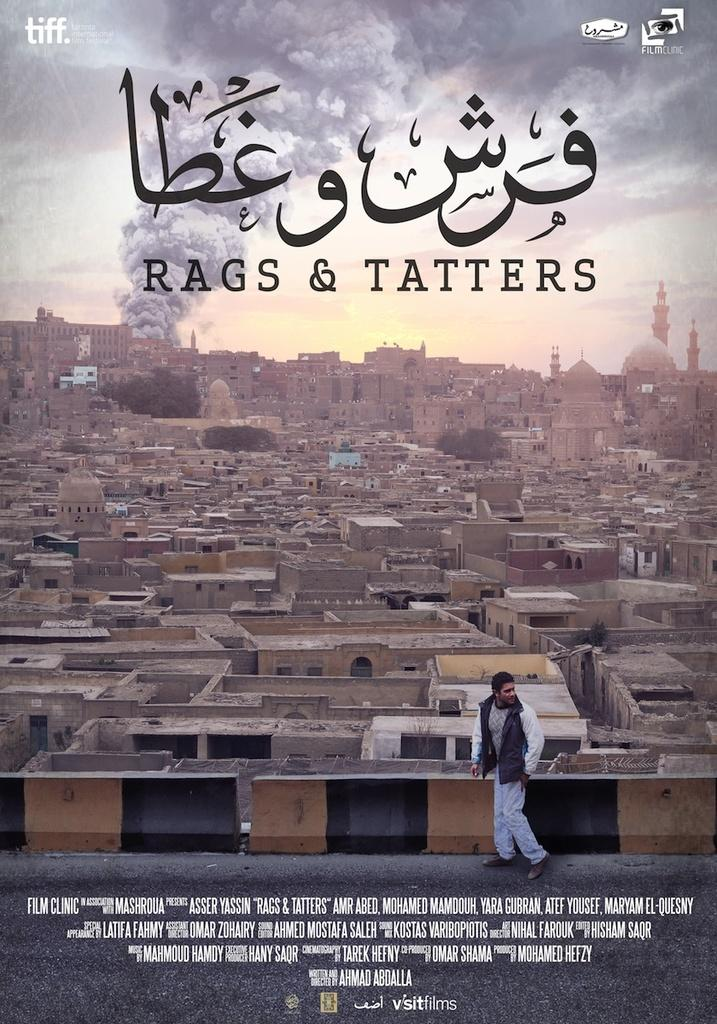<image>
Write a terse but informative summary of the picture. Rags and tatters poster with muslim writing underneath of a city 